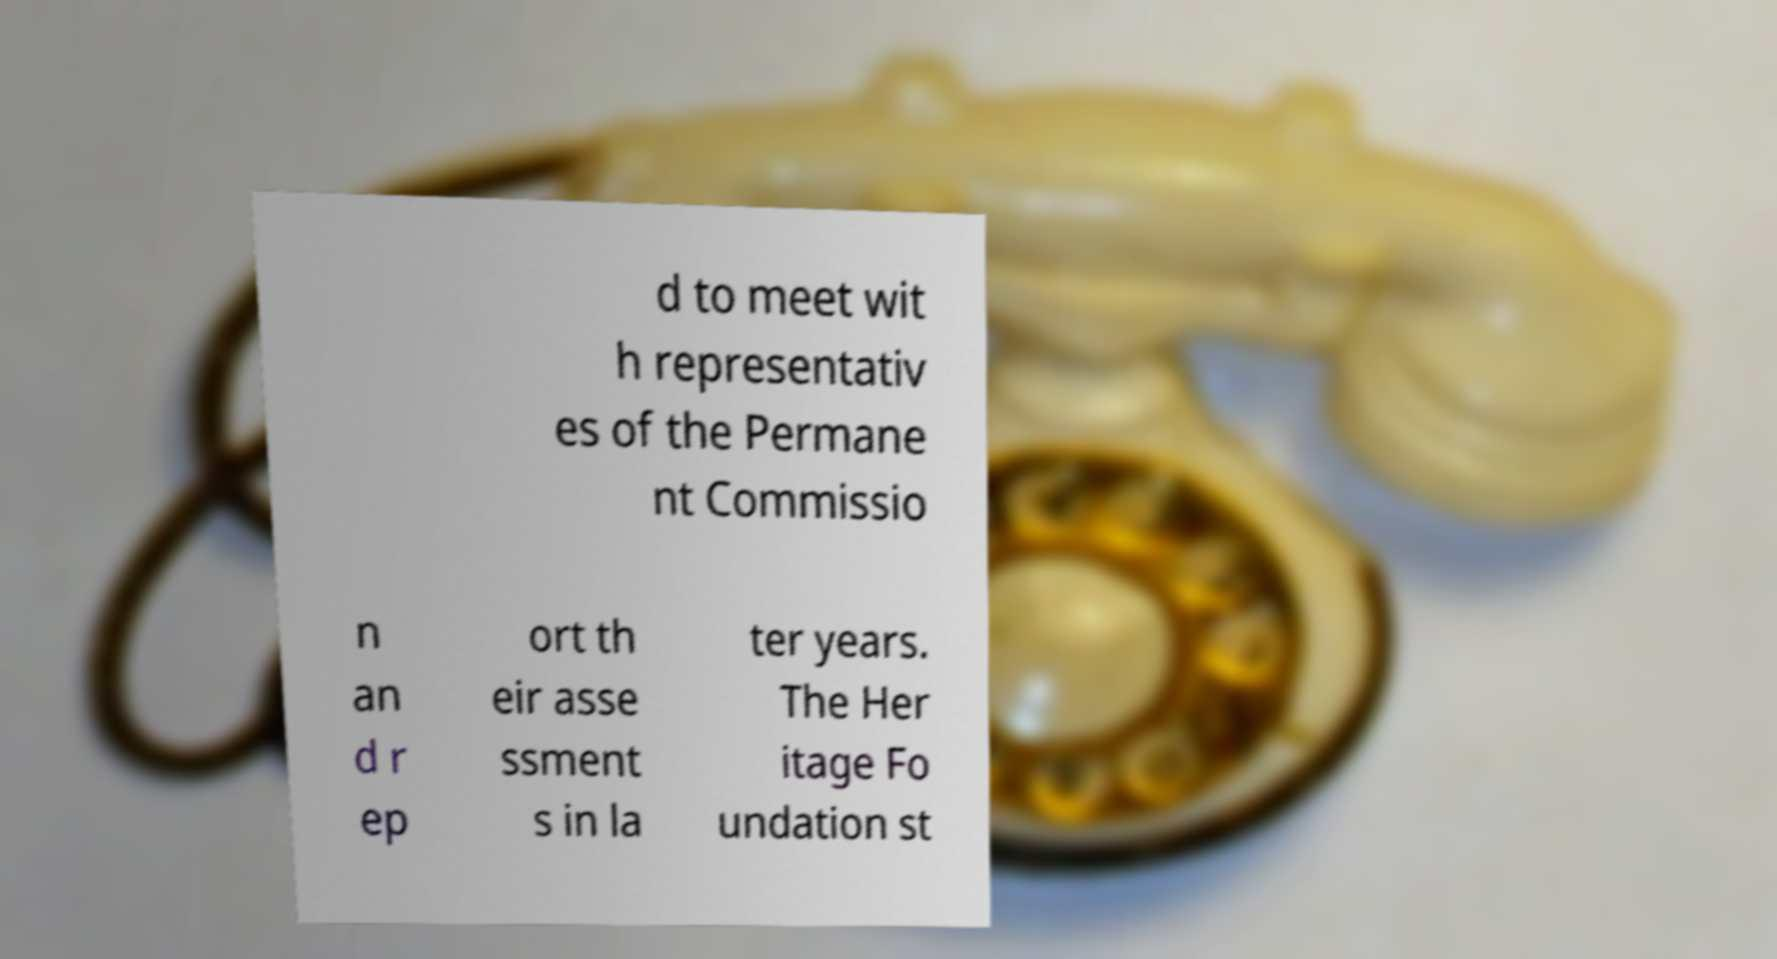I need the written content from this picture converted into text. Can you do that? d to meet wit h representativ es of the Permane nt Commissio n an d r ep ort th eir asse ssment s in la ter years. The Her itage Fo undation st 